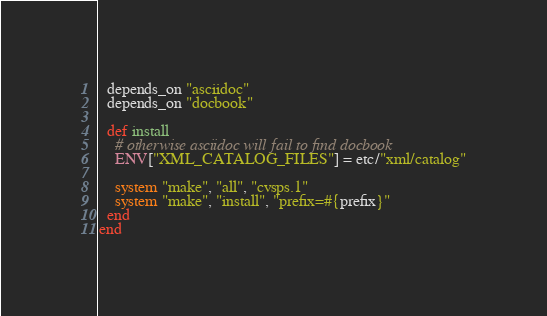<code> <loc_0><loc_0><loc_500><loc_500><_Ruby_>  depends_on "asciidoc"
  depends_on "docbook"

  def install
    # otherwise asciidoc will fail to find docbook
    ENV["XML_CATALOG_FILES"] = etc/"xml/catalog"

    system "make", "all", "cvsps.1"
    system "make", "install", "prefix=#{prefix}"
  end
end
</code> 